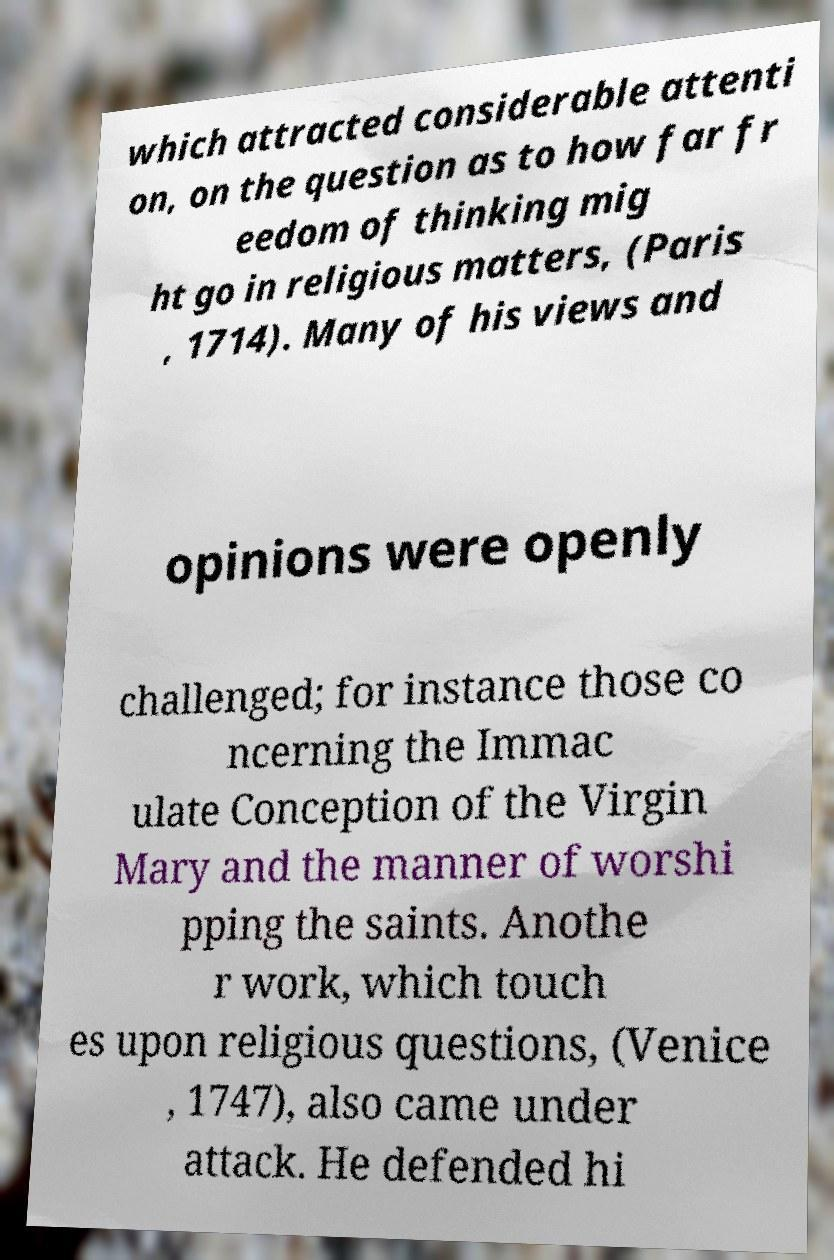I need the written content from this picture converted into text. Can you do that? which attracted considerable attenti on, on the question as to how far fr eedom of thinking mig ht go in religious matters, (Paris , 1714). Many of his views and opinions were openly challenged; for instance those co ncerning the Immac ulate Conception of the Virgin Mary and the manner of worshi pping the saints. Anothe r work, which touch es upon religious questions, (Venice , 1747), also came under attack. He defended hi 